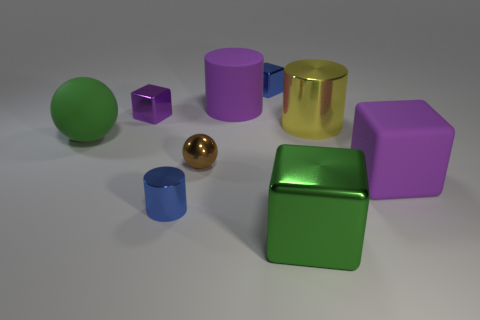Subtract 1 cubes. How many cubes are left? 3 Subtract all cylinders. How many objects are left? 6 Add 3 big metallic things. How many big metallic things are left? 5 Add 9 large spheres. How many large spheres exist? 10 Subtract 1 blue cubes. How many objects are left? 8 Subtract all large matte spheres. Subtract all big cylinders. How many objects are left? 6 